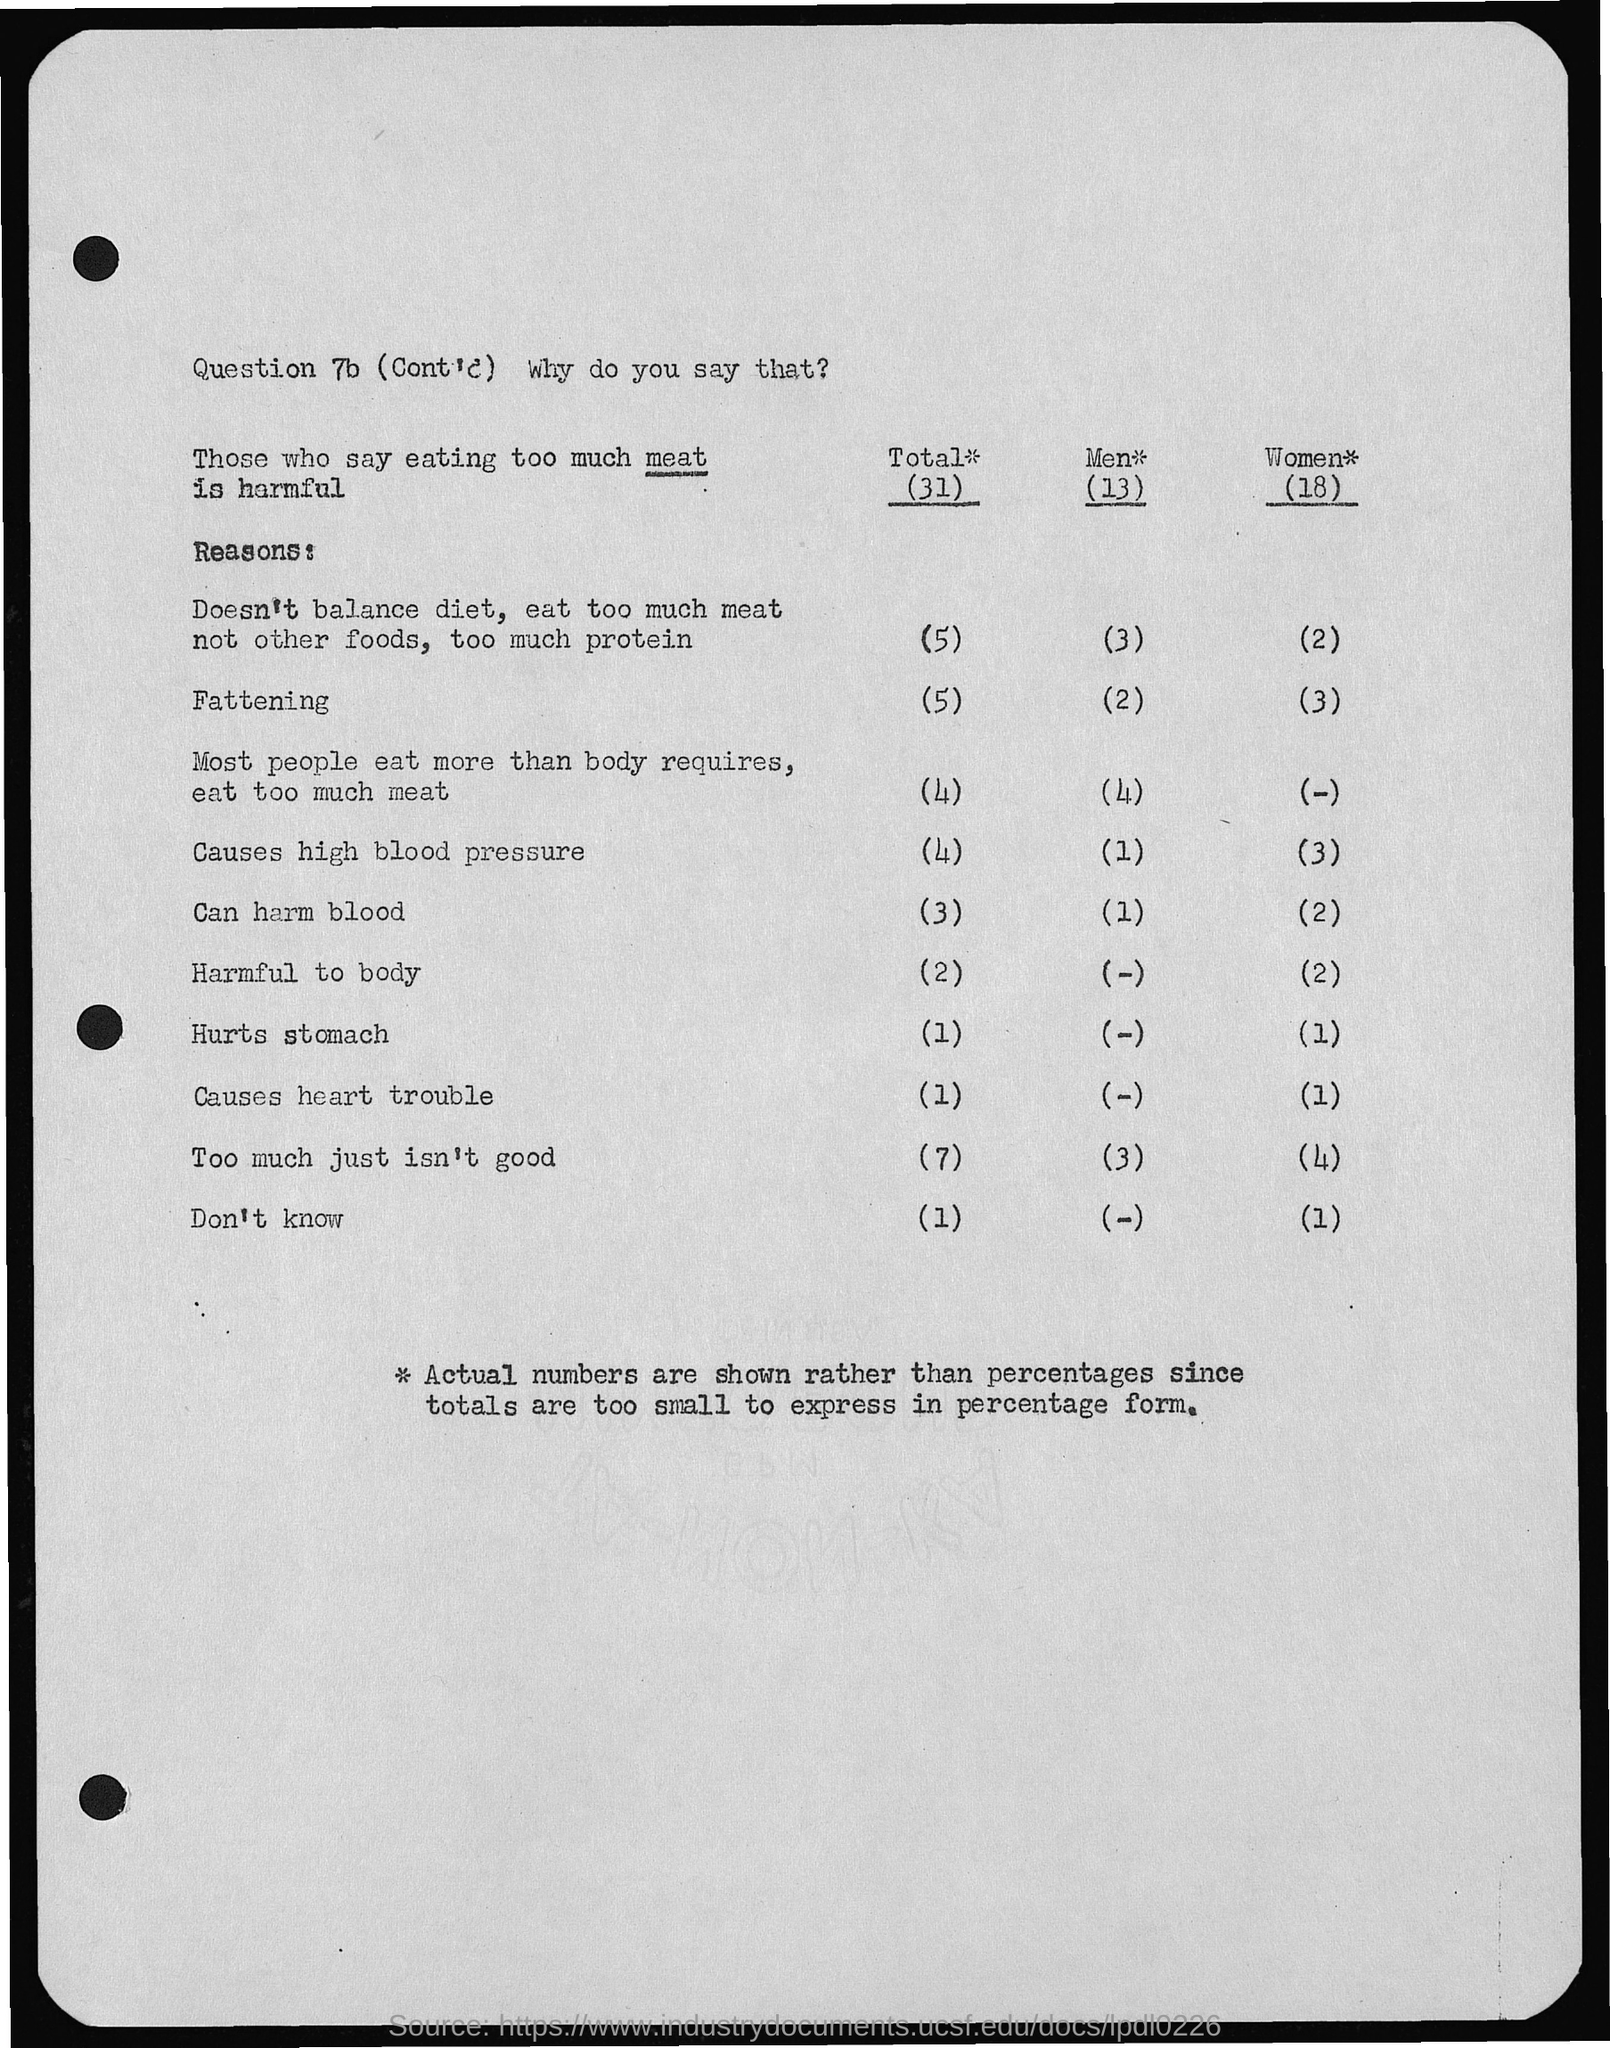Highlight a few significant elements in this photo. According to a recent survey, 13% of men believe that consuming too much meat is harmful to their health. Approximately 3% of men do not follow a balanced diet and consume excessive amounts of meat. According to recent studies, it is estimated that approximately 2% of men become fatter as a result of consuming meat. A significant number of individuals believe that consuming an excessive amount of meat can be detrimental to one's health (31). A significant number of women become overweight as a result of consuming meat. 